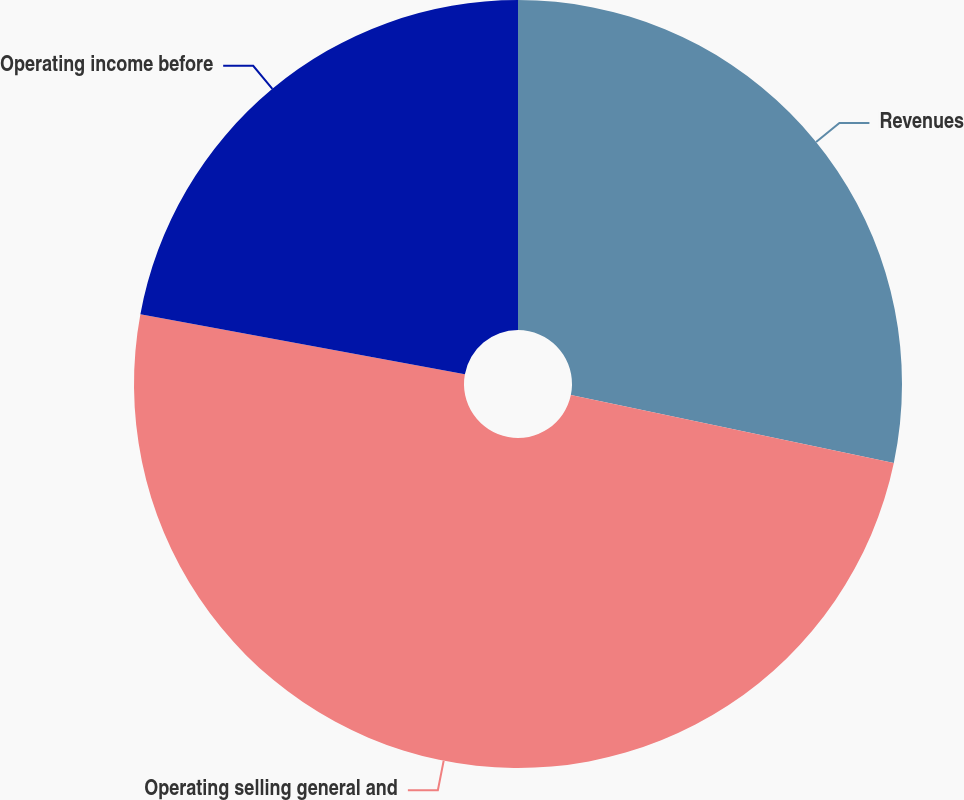<chart> <loc_0><loc_0><loc_500><loc_500><pie_chart><fcel>Revenues<fcel>Operating selling general and<fcel>Operating income before<nl><fcel>28.29%<fcel>49.61%<fcel>22.09%<nl></chart> 